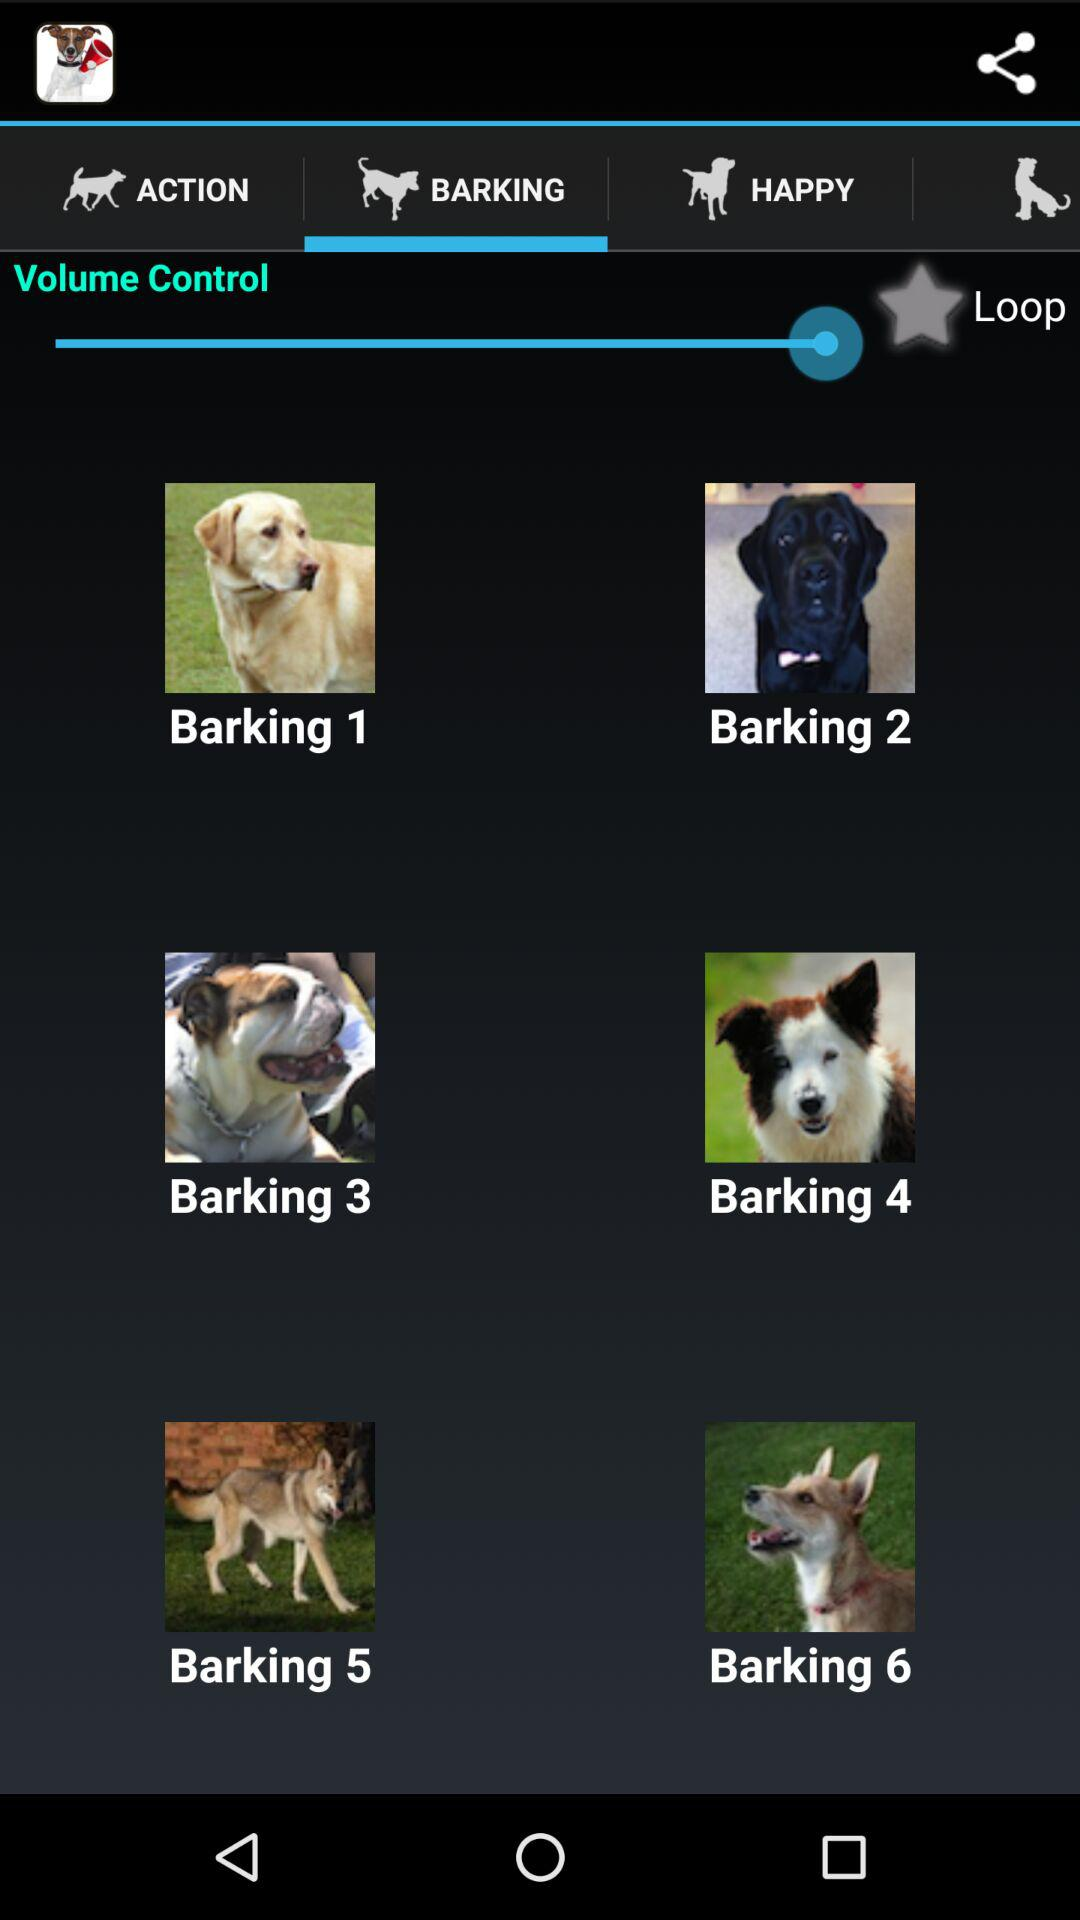How long is "Barking 5"?
When the provided information is insufficient, respond with <no answer>. <no answer> 